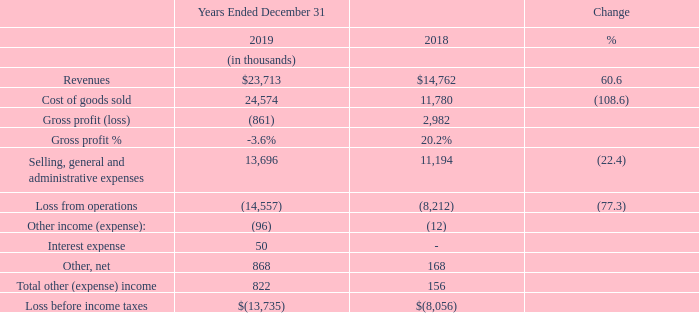ITEM 7. MANAGEMENT’S DISCUSSION AND ANALYSIS OF FINANCIAL CONDITION AND RESULTS OF OPERATIONS
See Note 3 of our Notes to Consolidated Financial Statements for a discussion of 2019 and 2018 acquisitions.
Results of Operations
Revenues increased $9.0 million, or 61%, in 2019 compared to the prior year, with overall growth supported by the acquisition of Golden Ridge in November 2018, and MGI Grain in April 2019. Food product revenues increased 97% year over year, primarily due to the addition of new products for human consumption from Golden Ridge and MGI Grain. Animal feed product revenues increased 10%. Animal feed product growth was primarily due to increased buying from our existing SRB customer base.
Gross profit percentage decreased 23.8 percentage points to negative 3.6% in 2019 from 20.2% in the prior year. The decrease in gross profit was primarily attributable to operating losses at Golden Ridge due to an unfavorable contract to sell medium grain rice entered into by the seller of the mill and low levels of plant utilization in the latter half of the year while the mill was going through a planned upgrade cycle. With this project completed in early January 2020, we expect to see improved productivity and a positive contribution margin from Golden Ridge in 2020.
Selling, general and administrative (SG&A) expenses were $13.7 million in 2019, compared to $11.2 million in 2018, an increase of $2.5 million, or 22.4%. Outside services increased $1.1 million in 2019, compared to the prior year, primarily as a result of higher outside accounting, legal and professional fees associated with the acquisition of Golden Ridge and MGI Grain. Salary, wages and benefit related expenses increased $1.1 million in 2019, compared to the prior year, driven substantially by equity grants and outside labor costs. Bad debt expense increased $0.2 million and rent expense increased $0.1 million in 2019, compared to the prior year.
Other, net was $0.9 million for 2019 compared to $0.2 million in 2018. This increase was primarily related to the settlement of a net working capital dispute and other issues with the seller of Golden Ridge.
What are the respective revenues from operations in 2018 and 2019?
Answer scale should be: thousand. $14,762, $23,713. What are the respective cost of goods sold from operations in 2018 and 2019?
Answer scale should be: thousand. 11,780, 24,574. What are the respective selling, general and administrative expenses from operations in 2018 and 2019?
Answer scale should be: thousand. 11,194, 13,696. What is the average revenues from operations in 2018 and 2019?
Answer scale should be: thousand. ($14,762 + $23,713)/2 
Answer: 19237.5. What is the percentage change in the cost of goods sold from operations in 2018 and 2019?
Answer scale should be: percent. (24,574 - 11,780)/11,780 
Answer: 108.61. What is the percentage change in selling, general and administrative expenses from operations in 2018 and 2019?
Answer scale should be: percent. (13,696 - 11,194)/11,194 
Answer: 22.35. 